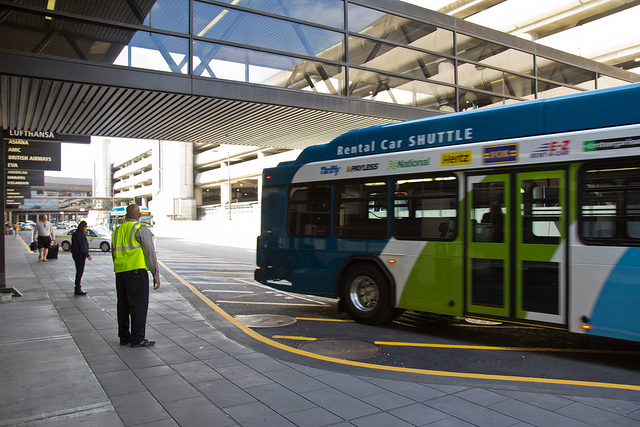<image>What country is this? I am not sure about the exact country, but it might be the USA. What country is this? I don't know what country this is. It could be the USA or America. 